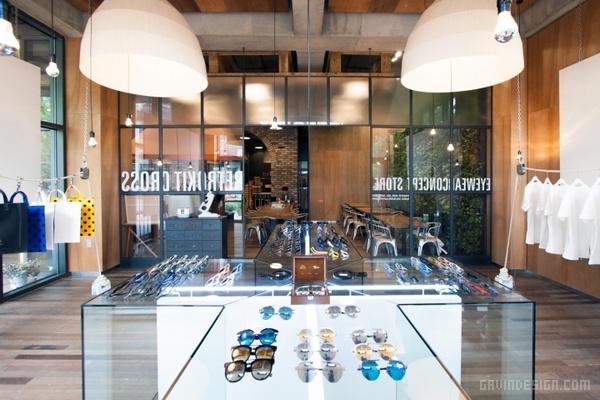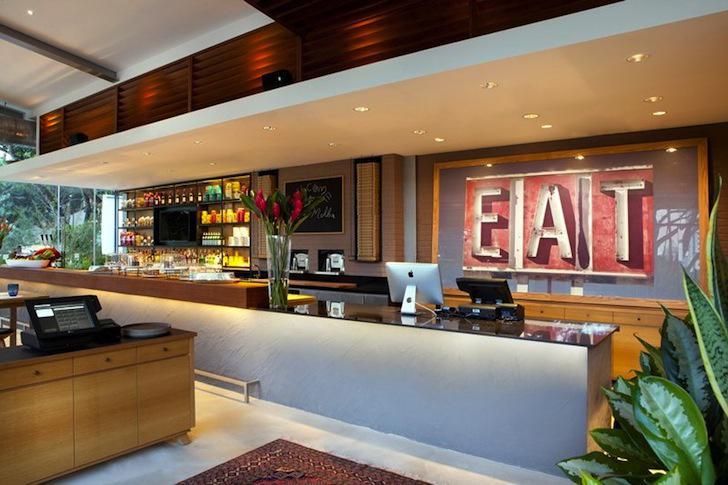The first image is the image on the left, the second image is the image on the right. Evaluate the accuracy of this statement regarding the images: "Both images in the pair show a cafe where coffee or pastries are served.". Is it true? Answer yes or no. No. The first image is the image on the left, the second image is the image on the right. For the images displayed, is the sentence "There are stools at the bar." factually correct? Answer yes or no. No. 